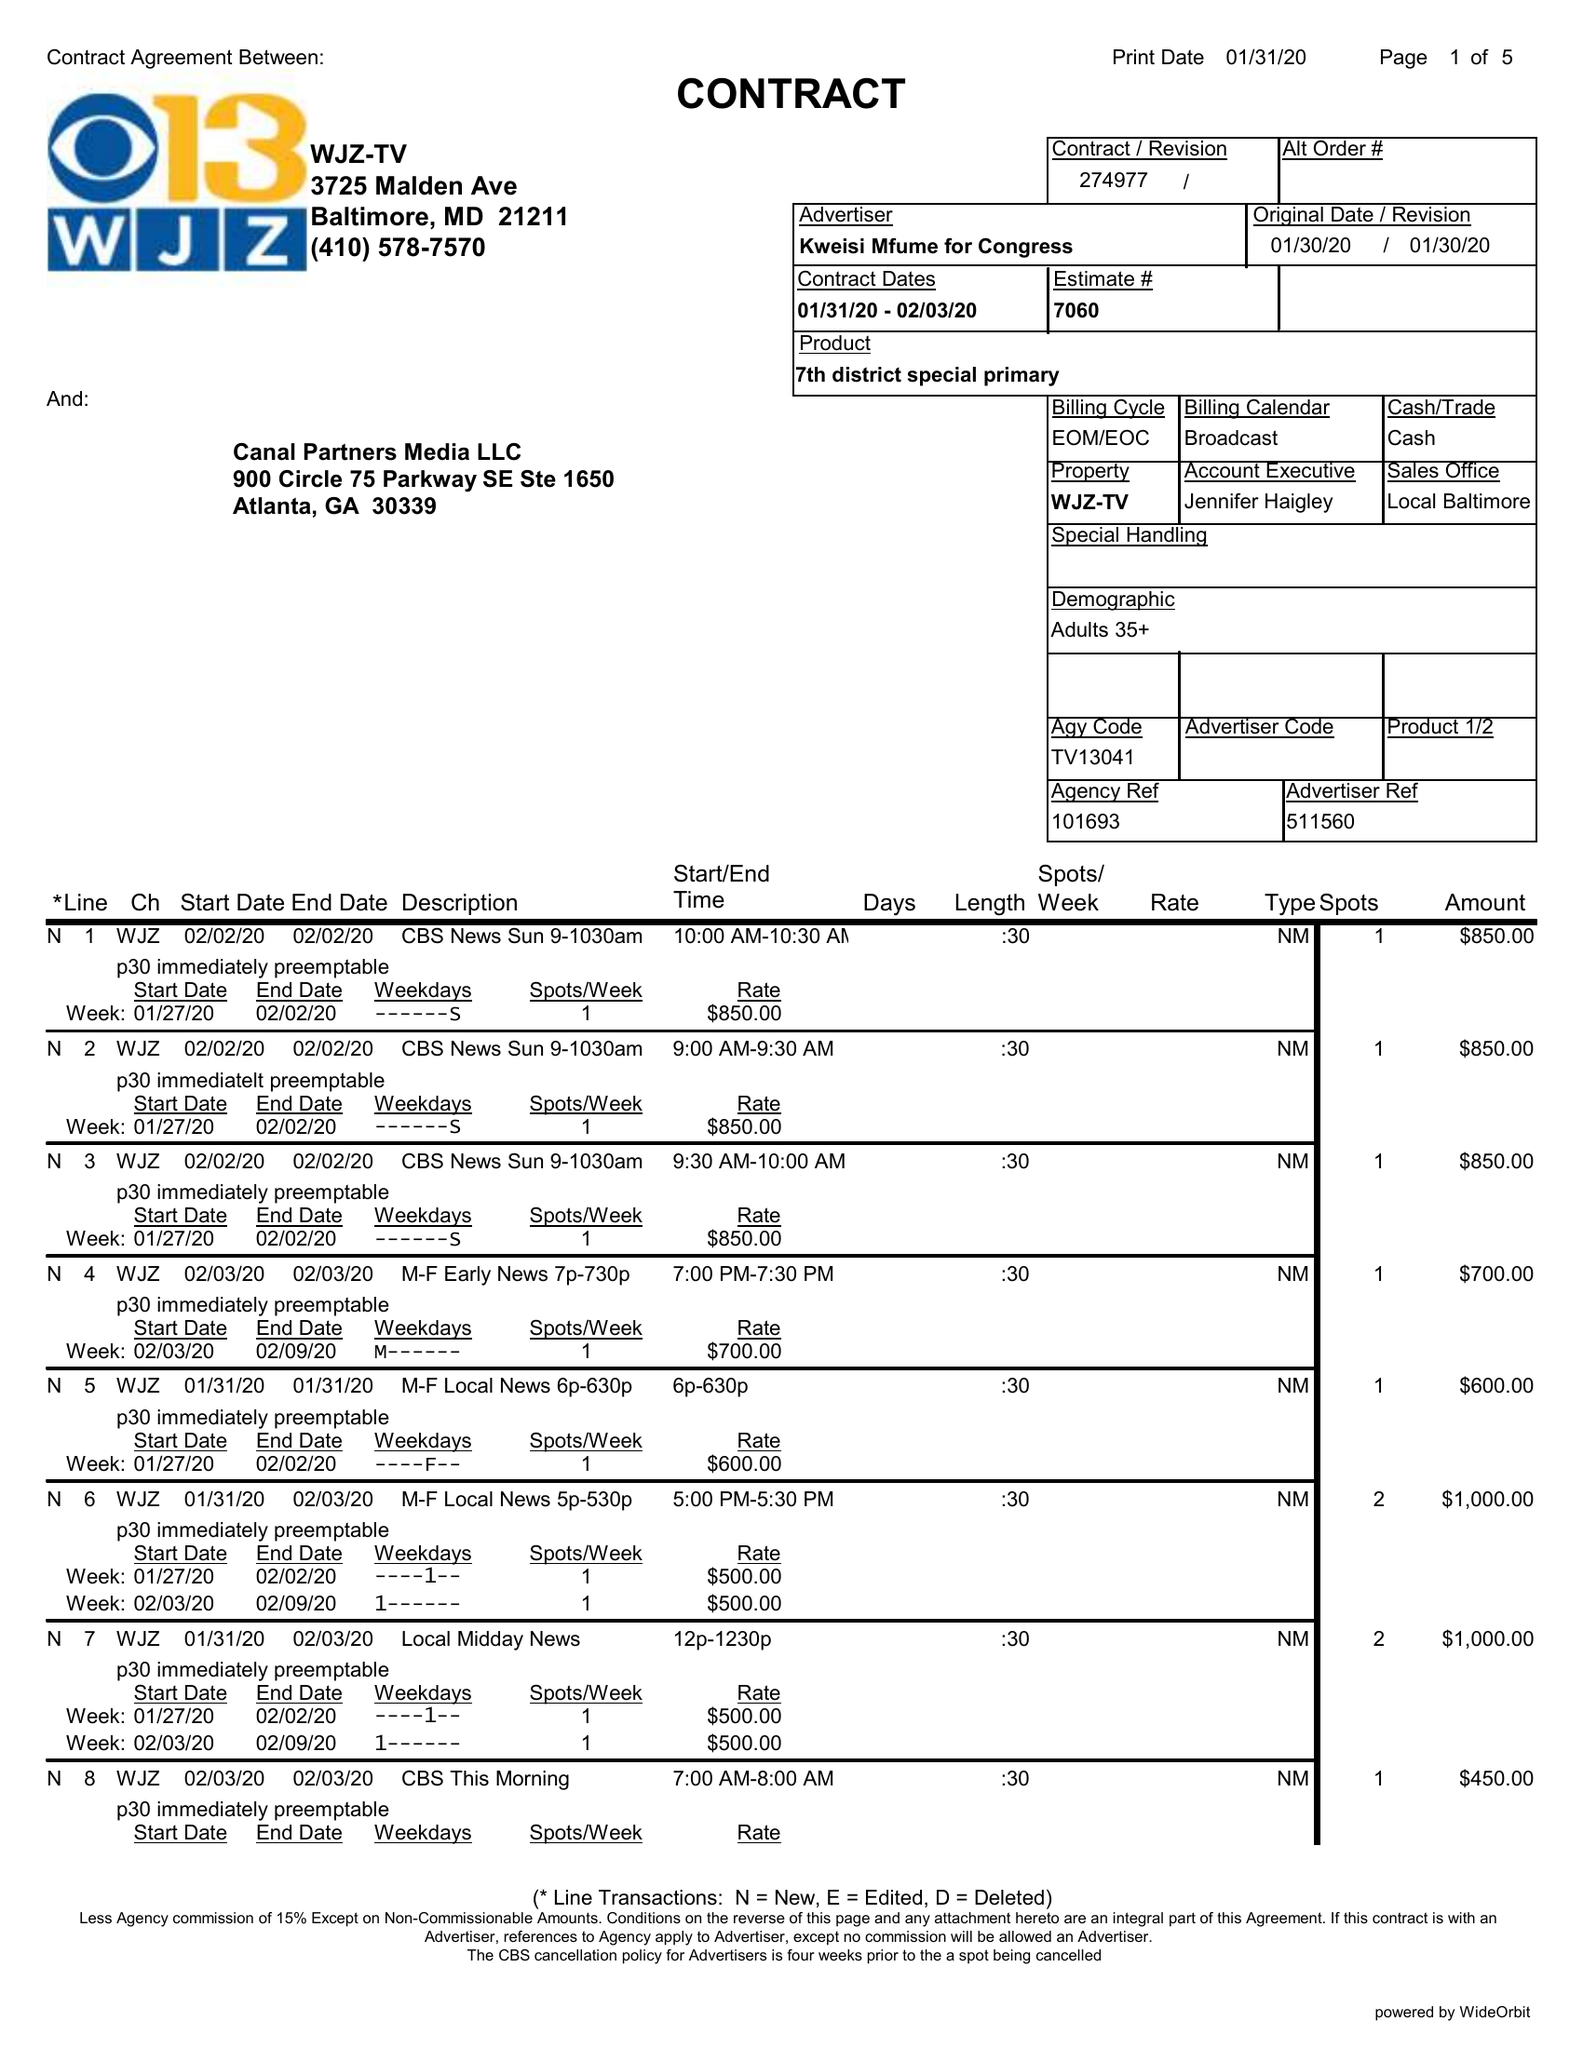What is the value for the advertiser?
Answer the question using a single word or phrase. KWEISI MFUME FOR CONGRESS 